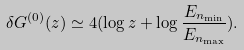Convert formula to latex. <formula><loc_0><loc_0><loc_500><loc_500>\delta G ^ { ( 0 ) } ( z ) \simeq 4 ( \log z + \log \frac { E _ { n _ { \min } } } { E _ { n _ { \max } } } ) .</formula> 